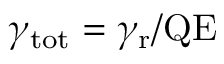Convert formula to latex. <formula><loc_0><loc_0><loc_500><loc_500>\gamma _ { t o t } = \gamma _ { r } / Q E</formula> 